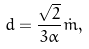Convert formula to latex. <formula><loc_0><loc_0><loc_500><loc_500>d = \frac { \sqrt { 2 } } { 3 \alpha } \dot { m } ,</formula> 